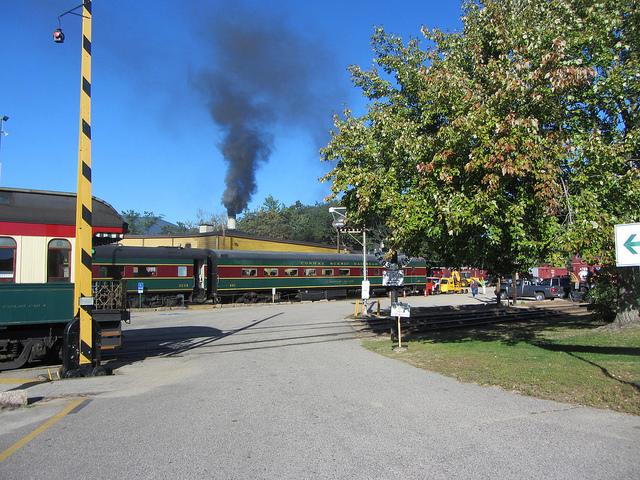Why is the smoke black?
Answer briefly. Coal. Does the shrub have flowers on it?
Keep it brief. No. What colors are the poles?
Short answer required. Yellow and black. Is there something on fire?
Concise answer only. No. 